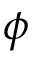Convert formula to latex. <formula><loc_0><loc_0><loc_500><loc_500>\phi</formula> 